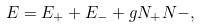Convert formula to latex. <formula><loc_0><loc_0><loc_500><loc_500>E = E _ { + } + E _ { - } + g N _ { + } N - ,</formula> 